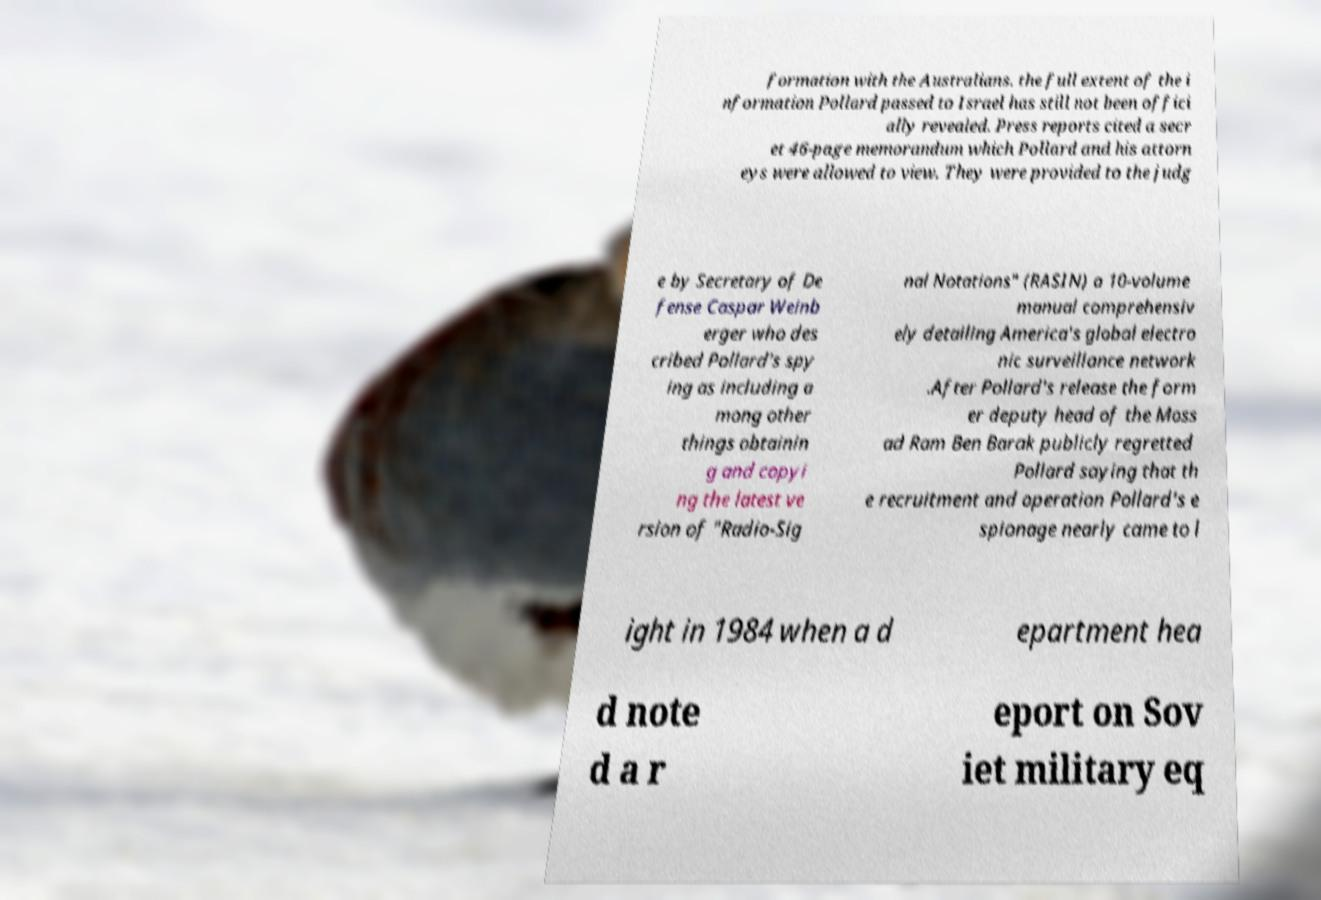Could you assist in decoding the text presented in this image and type it out clearly? formation with the Australians. the full extent of the i nformation Pollard passed to Israel has still not been offici ally revealed. Press reports cited a secr et 46-page memorandum which Pollard and his attorn eys were allowed to view. They were provided to the judg e by Secretary of De fense Caspar Weinb erger who des cribed Pollard's spy ing as including a mong other things obtainin g and copyi ng the latest ve rsion of "Radio-Sig nal Notations" (RASIN) a 10-volume manual comprehensiv ely detailing America's global electro nic surveillance network .After Pollard's release the form er deputy head of the Moss ad Ram Ben Barak publicly regretted Pollard saying that th e recruitment and operation Pollard's e spionage nearly came to l ight in 1984 when a d epartment hea d note d a r eport on Sov iet military eq 